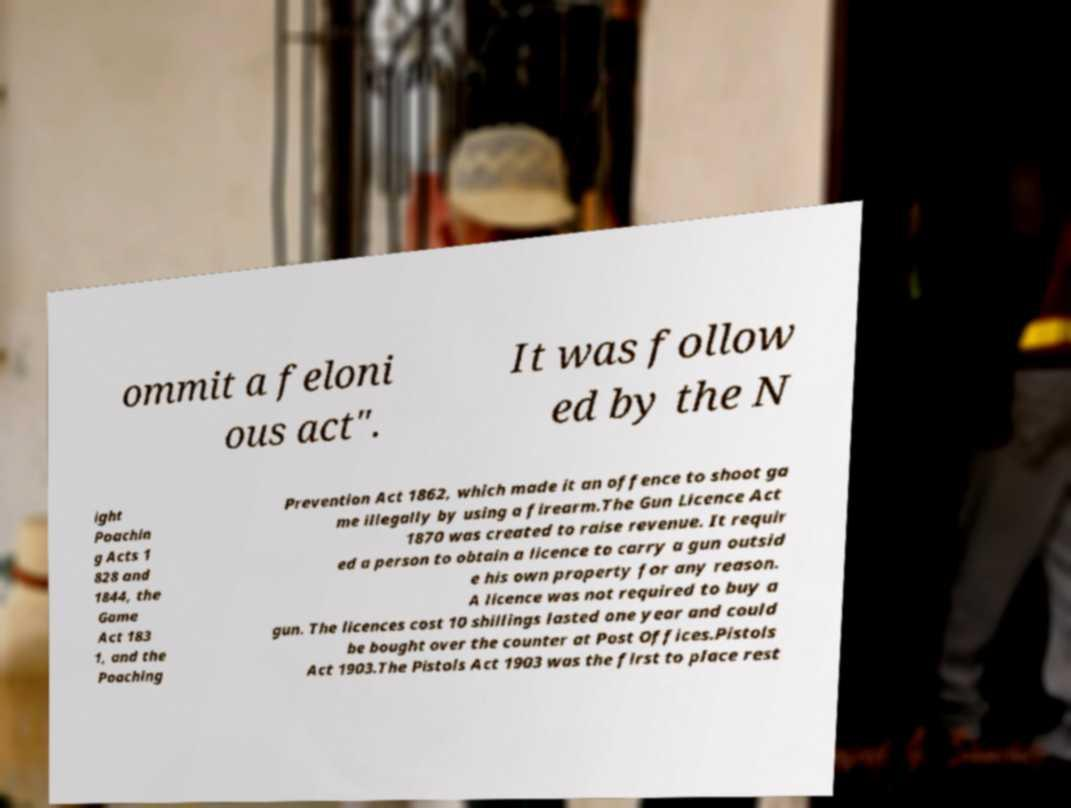Can you read and provide the text displayed in the image?This photo seems to have some interesting text. Can you extract and type it out for me? ommit a feloni ous act". It was follow ed by the N ight Poachin g Acts 1 828 and 1844, the Game Act 183 1, and the Poaching Prevention Act 1862, which made it an offence to shoot ga me illegally by using a firearm.The Gun Licence Act 1870 was created to raise revenue. It requir ed a person to obtain a licence to carry a gun outsid e his own property for any reason. A licence was not required to buy a gun. The licences cost 10 shillings lasted one year and could be bought over the counter at Post Offices.Pistols Act 1903.The Pistols Act 1903 was the first to place rest 